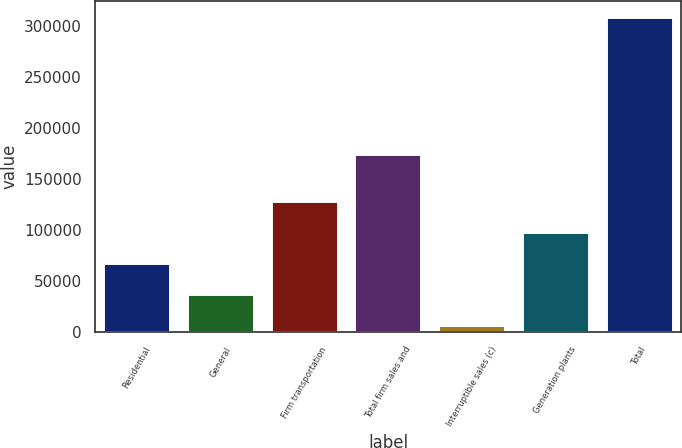<chart> <loc_0><loc_0><loc_500><loc_500><bar_chart><fcel>Residential<fcel>General<fcel>Firm transportation<fcel>Total firm sales and<fcel>Interruptible sales (c)<fcel>Generation plants<fcel>Total<nl><fcel>67791.4<fcel>37571.2<fcel>128232<fcel>174777<fcel>7351<fcel>98011.6<fcel>309553<nl></chart> 